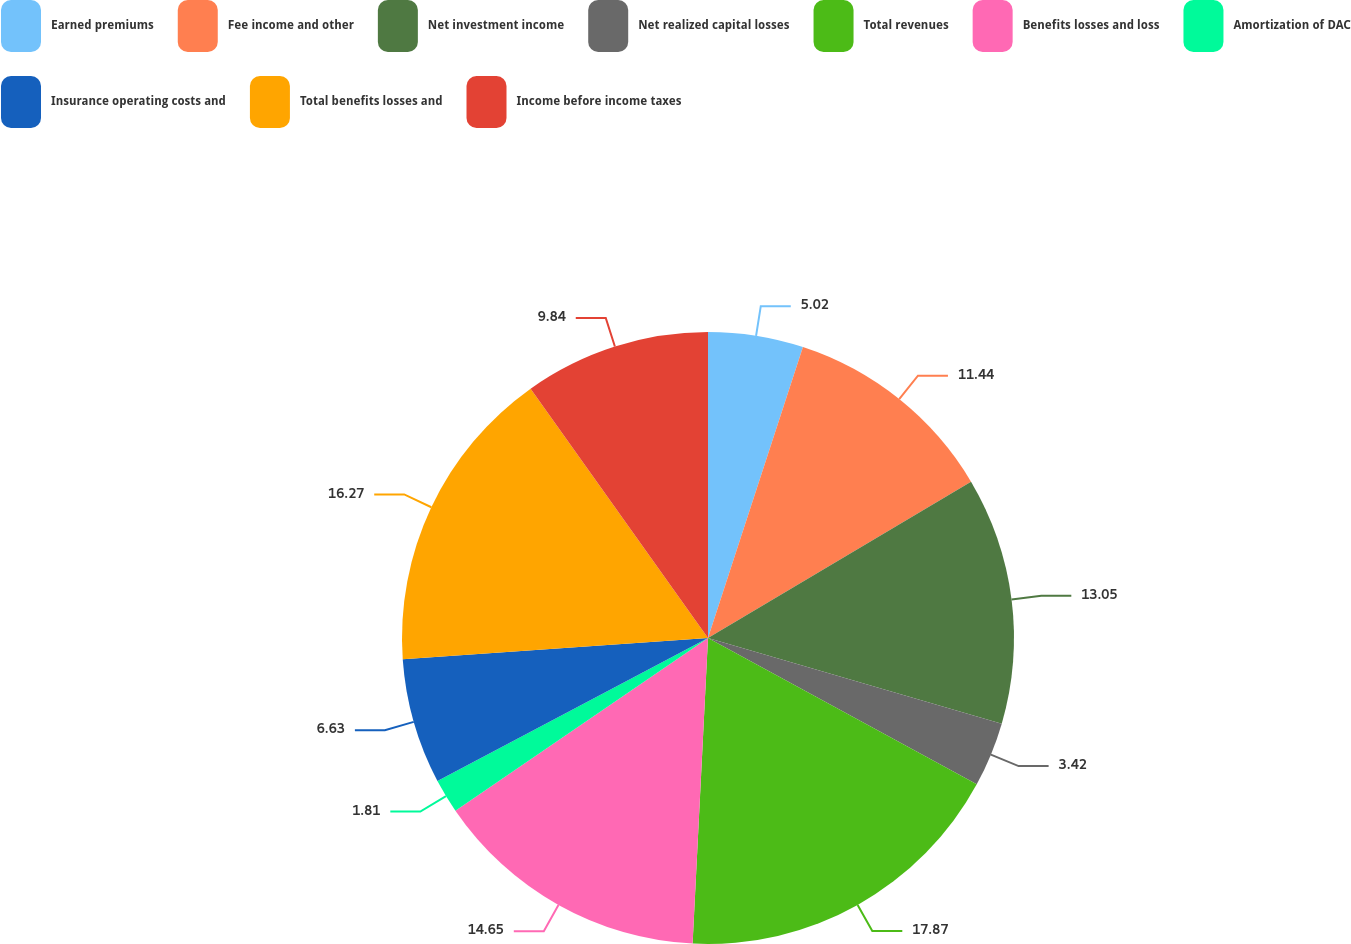<chart> <loc_0><loc_0><loc_500><loc_500><pie_chart><fcel>Earned premiums<fcel>Fee income and other<fcel>Net investment income<fcel>Net realized capital losses<fcel>Total revenues<fcel>Benefits losses and loss<fcel>Amortization of DAC<fcel>Insurance operating costs and<fcel>Total benefits losses and<fcel>Income before income taxes<nl><fcel>5.02%<fcel>11.44%<fcel>13.05%<fcel>3.42%<fcel>17.86%<fcel>14.65%<fcel>1.81%<fcel>6.63%<fcel>16.26%<fcel>9.84%<nl></chart> 